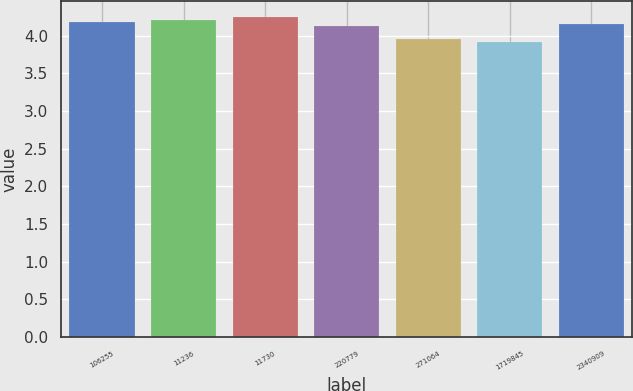Convert chart to OTSL. <chart><loc_0><loc_0><loc_500><loc_500><bar_chart><fcel>106255<fcel>11236<fcel>11730<fcel>220779<fcel>271064<fcel>1719845<fcel>2340909<nl><fcel>4.18<fcel>4.21<fcel>4.24<fcel>4.12<fcel>3.95<fcel>3.91<fcel>4.15<nl></chart> 